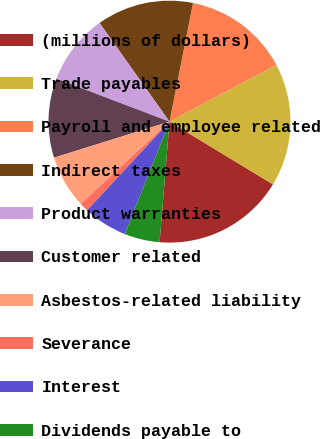Convert chart. <chart><loc_0><loc_0><loc_500><loc_500><pie_chart><fcel>(millions of dollars)<fcel>Trade payables<fcel>Payroll and employee related<fcel>Indirect taxes<fcel>Product warranties<fcel>Customer related<fcel>Asbestos-related liability<fcel>Severance<fcel>Interest<fcel>Dividends payable to<nl><fcel>17.63%<fcel>16.45%<fcel>14.11%<fcel>12.93%<fcel>9.41%<fcel>10.59%<fcel>7.07%<fcel>1.2%<fcel>5.89%<fcel>4.72%<nl></chart> 